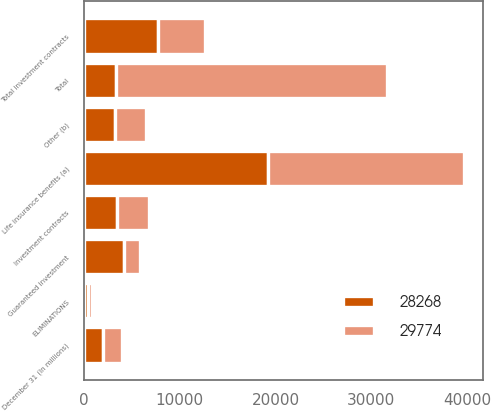Convert chart to OTSL. <chart><loc_0><loc_0><loc_500><loc_500><stacked_bar_chart><ecel><fcel>December 31 (In millions)<fcel>Investment contracts<fcel>Guaranteed investment<fcel>Total investment contracts<fcel>Life insurance benefits (a)<fcel>Other (b)<fcel>ELIMINATIONS<fcel>Total<nl><fcel>29774<fcel>2012<fcel>3321<fcel>1644<fcel>4965<fcel>20427<fcel>3304<fcel>428<fcel>28268<nl><fcel>28268<fcel>2011<fcel>3493<fcel>4226<fcel>7719<fcel>19257<fcel>3222<fcel>424<fcel>3321<nl></chart> 